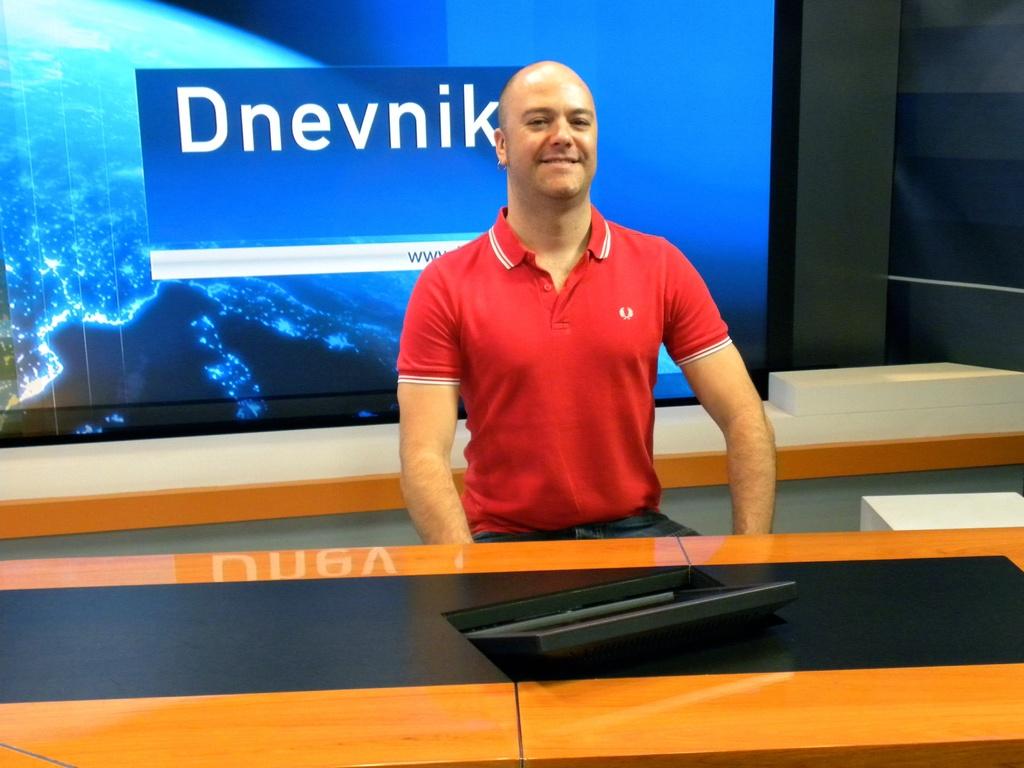What word is displayed on the screen behind the man?
Ensure brevity in your answer.  Dnevnik. Which group is this person in?
Make the answer very short. Dnevnik. 